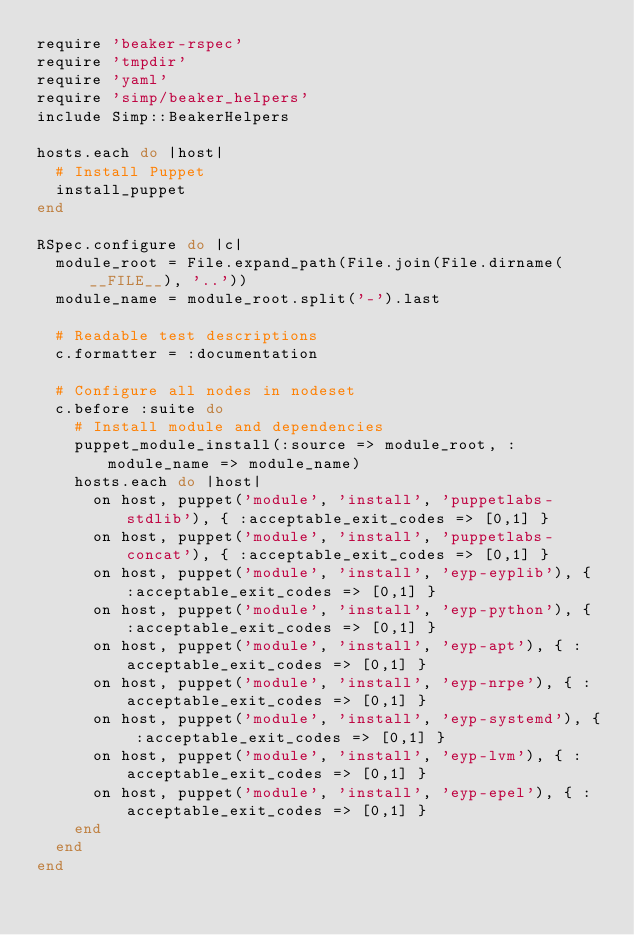<code> <loc_0><loc_0><loc_500><loc_500><_Ruby_>require 'beaker-rspec'
require 'tmpdir'
require 'yaml'
require 'simp/beaker_helpers'
include Simp::BeakerHelpers

hosts.each do |host|
  # Install Puppet
  install_puppet
end

RSpec.configure do |c|
  module_root = File.expand_path(File.join(File.dirname(__FILE__), '..'))
  module_name = module_root.split('-').last

  # Readable test descriptions
  c.formatter = :documentation

  # Configure all nodes in nodeset
  c.before :suite do
    # Install module and dependencies
    puppet_module_install(:source => module_root, :module_name => module_name)
    hosts.each do |host|
      on host, puppet('module', 'install', 'puppetlabs-stdlib'), { :acceptable_exit_codes => [0,1] }
      on host, puppet('module', 'install', 'puppetlabs-concat'), { :acceptable_exit_codes => [0,1] }
      on host, puppet('module', 'install', 'eyp-eyplib'), { :acceptable_exit_codes => [0,1] }
      on host, puppet('module', 'install', 'eyp-python'), { :acceptable_exit_codes => [0,1] }
      on host, puppet('module', 'install', 'eyp-apt'), { :acceptable_exit_codes => [0,1] }
      on host, puppet('module', 'install', 'eyp-nrpe'), { :acceptable_exit_codes => [0,1] }
      on host, puppet('module', 'install', 'eyp-systemd'), { :acceptable_exit_codes => [0,1] }
      on host, puppet('module', 'install', 'eyp-lvm'), { :acceptable_exit_codes => [0,1] }
      on host, puppet('module', 'install', 'eyp-epel'), { :acceptable_exit_codes => [0,1] }
    end
  end
end
</code> 